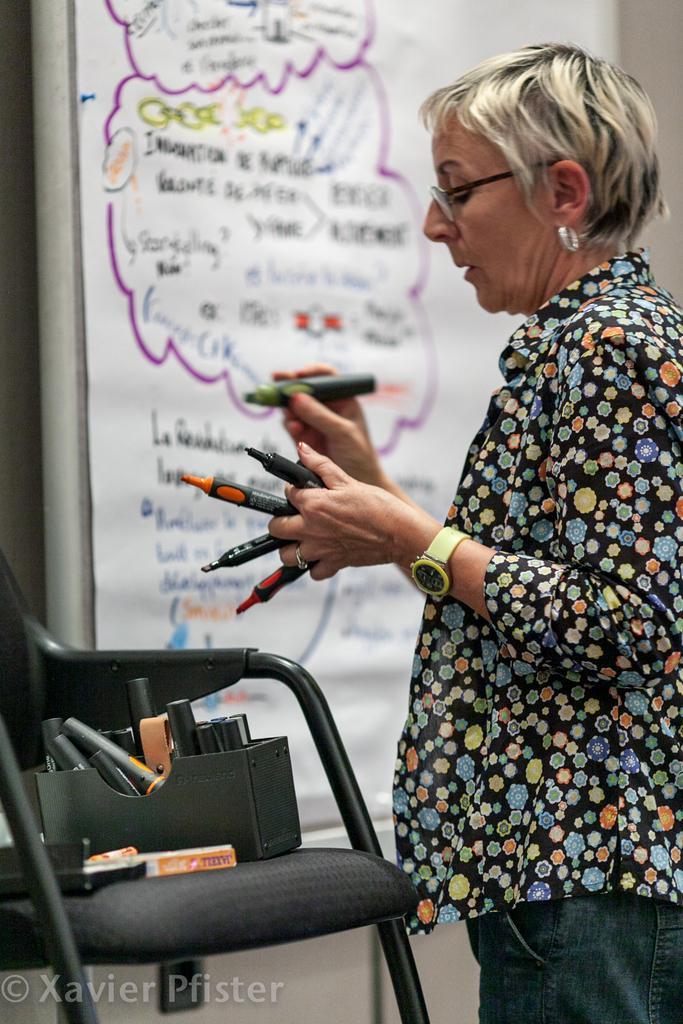Describe this image in one or two sentences. In this picture we can see a woman is standing and holding the marker pens. In front of the women there are some objects on the chair. Behind the woman, it looks like a whiteboard. On the image there is a watermark. 